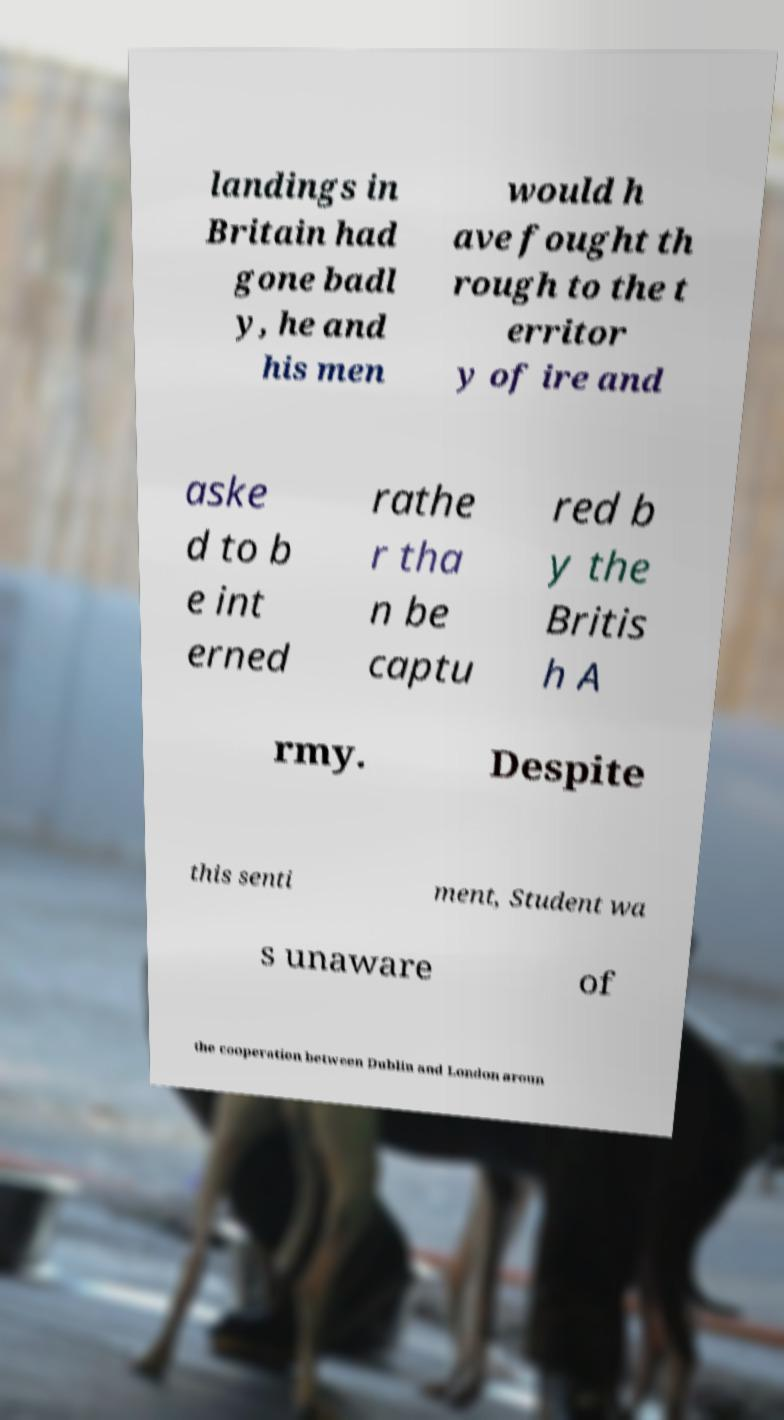Please read and relay the text visible in this image. What does it say? landings in Britain had gone badl y, he and his men would h ave fought th rough to the t erritor y of ire and aske d to b e int erned rathe r tha n be captu red b y the Britis h A rmy. Despite this senti ment, Student wa s unaware of the cooperation between Dublin and London aroun 